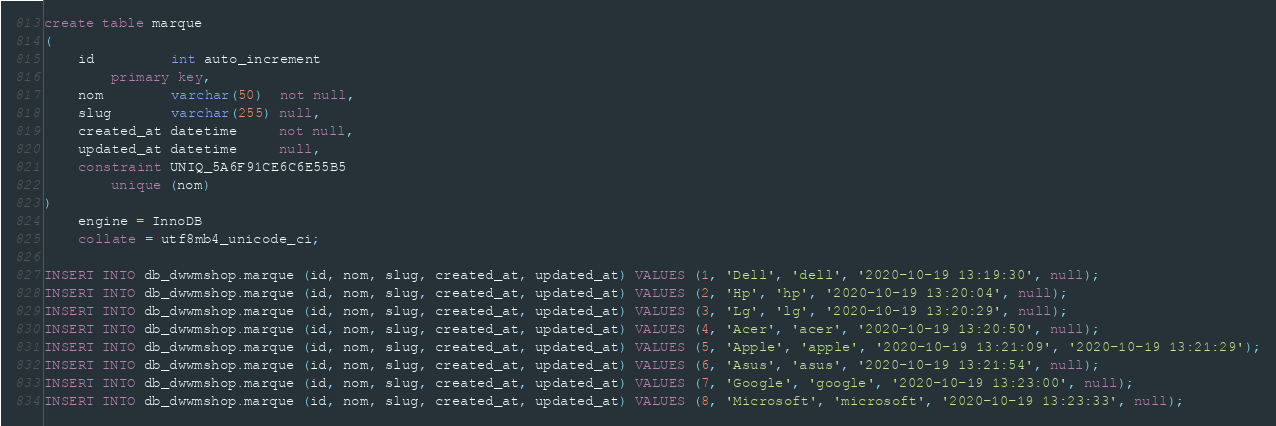Convert code to text. <code><loc_0><loc_0><loc_500><loc_500><_SQL_>create table marque
(
    id         int auto_increment
        primary key,
    nom        varchar(50)  not null,
    slug       varchar(255) null,
    created_at datetime     not null,
    updated_at datetime     null,
    constraint UNIQ_5A6F91CE6C6E55B5
        unique (nom)
)
    engine = InnoDB
    collate = utf8mb4_unicode_ci;

INSERT INTO db_dwwmshop.marque (id, nom, slug, created_at, updated_at) VALUES (1, 'Dell', 'dell', '2020-10-19 13:19:30', null);
INSERT INTO db_dwwmshop.marque (id, nom, slug, created_at, updated_at) VALUES (2, 'Hp', 'hp', '2020-10-19 13:20:04', null);
INSERT INTO db_dwwmshop.marque (id, nom, slug, created_at, updated_at) VALUES (3, 'Lg', 'lg', '2020-10-19 13:20:29', null);
INSERT INTO db_dwwmshop.marque (id, nom, slug, created_at, updated_at) VALUES (4, 'Acer', 'acer', '2020-10-19 13:20:50', null);
INSERT INTO db_dwwmshop.marque (id, nom, slug, created_at, updated_at) VALUES (5, 'Apple', 'apple', '2020-10-19 13:21:09', '2020-10-19 13:21:29');
INSERT INTO db_dwwmshop.marque (id, nom, slug, created_at, updated_at) VALUES (6, 'Asus', 'asus', '2020-10-19 13:21:54', null);
INSERT INTO db_dwwmshop.marque (id, nom, slug, created_at, updated_at) VALUES (7, 'Google', 'google', '2020-10-19 13:23:00', null);
INSERT INTO db_dwwmshop.marque (id, nom, slug, created_at, updated_at) VALUES (8, 'Microsoft', 'microsoft', '2020-10-19 13:23:33', null);</code> 